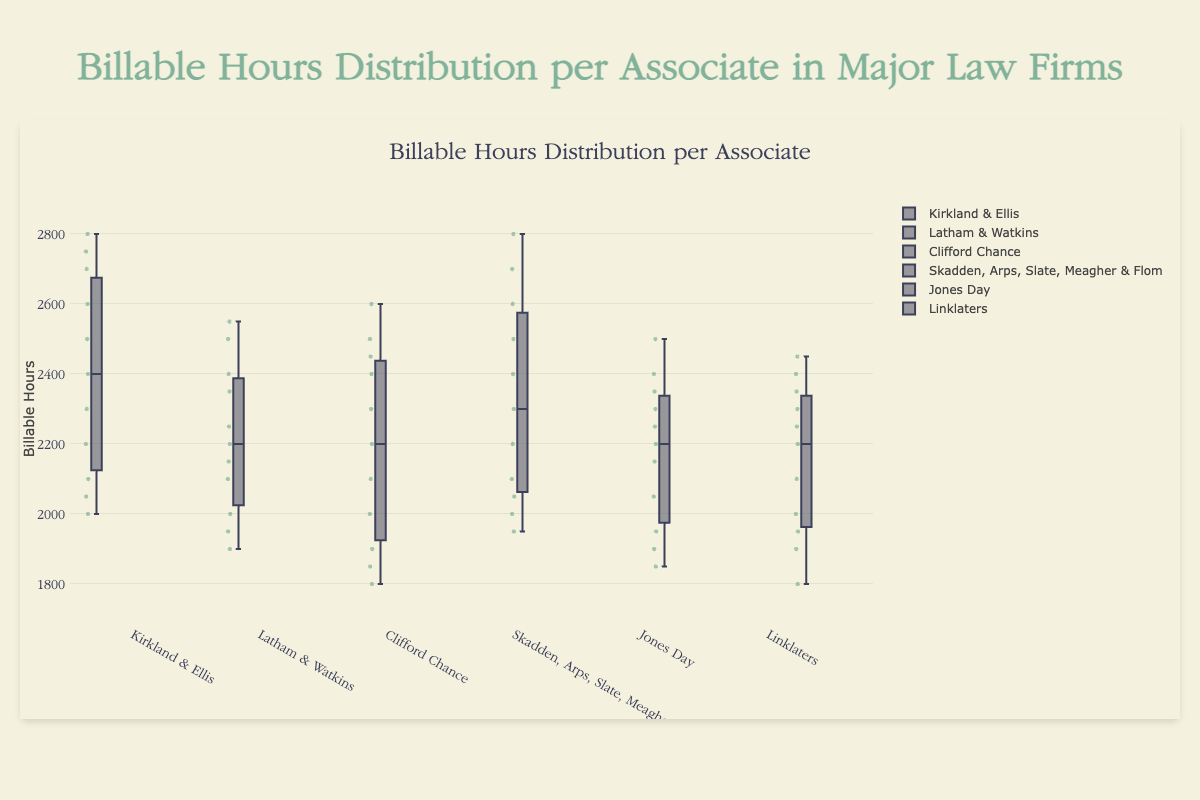What is the title of the figure? The title of the figure is displayed at the top center and provides a summary of what the figure represents.
Answer: Billable Hours Distribution per Associate in Major Law Firms How many law firms are represented in the box plot? By counting the distinct firms' names on the x-axis labels of the box plot, we can determine the number of represented firms.
Answer: 6 Which law firm has the highest median billable hours? In a box plot, the median is marked by a line inside the box. By identifying the firm with the highest median line, we find the law firm with the highest median billable hours.
Answer: Kirkland & Ellis What is the range of billable hours for Jones Day associates? The range in a box plot is indicated by the minimum and maximum whiskers. For Jones Day, find the minimum and maximum whiskers to determine the range.
Answer: 1850 to 2500 Which firm has the largest interquartile range (IQR) of billable hours? The IQR is the difference between the third quartile (Q3) and the first quartile (Q1). Compare the IQR (boxes' height) of all firms in the box plot to determine which is the largest.
Answer: Skadden, Arps, Slate, Meagher & Flom What is the median billable hours for Clifford Chance? Identify the median line within the box plot for Clifford Chance, as this line represents the median value.
Answer: 2200 Which firm has the smallest spread of billable hours? The spread is determined by the total range from the lowest whisker to the highest whisker. By identifying the smallest range among the boxes, the firm with the smallest spread is highlighted.
Answer: Linklaters How does the billable hours for Latham & Watkins compare to Linklaters? Compare the medians and ranges of the two firms’ box plots, noting differences in the distribution and central values.
Answer: Latham & Watkins generally has a higher median and slightly wider spread compared to Linklaters What can be inferred about the distribution of Kirkland & Ellis’s billable hours? Observing the box plot of Kirkland & Ellis, note the position and length of the whiskers, the size of the box, and the placement of the median line. Infer the spread, central tendency, and possible outliers.
Answer: The median is high, the IQR is wide indicating varied associate hours, with no extreme outliers Which firm has the highest variability in billable hours? Variability can be assessed by looking at the range and IQR. A box plot with a larger range and wider IQR indicates higher variability.
Answer: Kirkland & Ellis 